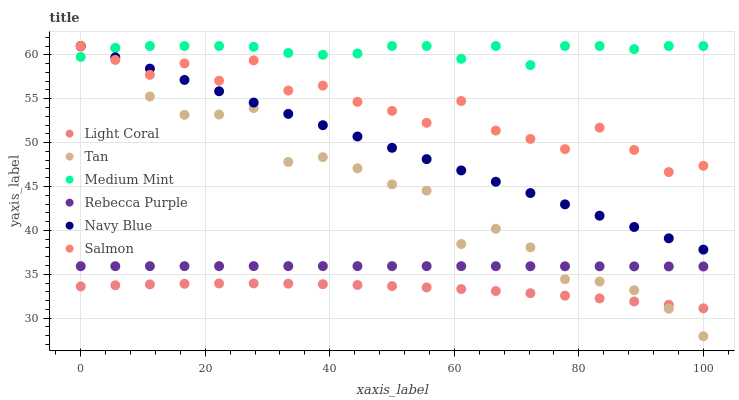Does Light Coral have the minimum area under the curve?
Answer yes or no. Yes. Does Medium Mint have the maximum area under the curve?
Answer yes or no. Yes. Does Navy Blue have the minimum area under the curve?
Answer yes or no. No. Does Navy Blue have the maximum area under the curve?
Answer yes or no. No. Is Navy Blue the smoothest?
Answer yes or no. Yes. Is Tan the roughest?
Answer yes or no. Yes. Is Salmon the smoothest?
Answer yes or no. No. Is Salmon the roughest?
Answer yes or no. No. Does Tan have the lowest value?
Answer yes or no. Yes. Does Navy Blue have the lowest value?
Answer yes or no. No. Does Salmon have the highest value?
Answer yes or no. Yes. Does Light Coral have the highest value?
Answer yes or no. No. Is Light Coral less than Navy Blue?
Answer yes or no. Yes. Is Salmon greater than Light Coral?
Answer yes or no. Yes. Does Light Coral intersect Tan?
Answer yes or no. Yes. Is Light Coral less than Tan?
Answer yes or no. No. Is Light Coral greater than Tan?
Answer yes or no. No. Does Light Coral intersect Navy Blue?
Answer yes or no. No. 